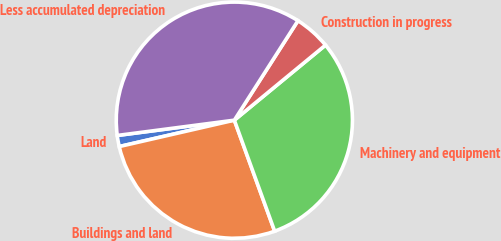Convert chart. <chart><loc_0><loc_0><loc_500><loc_500><pie_chart><fcel>Land<fcel>Buildings and land<fcel>Machinery and equipment<fcel>Construction in progress<fcel>Less accumulated depreciation<nl><fcel>1.52%<fcel>26.96%<fcel>30.42%<fcel>4.98%<fcel>36.12%<nl></chart> 